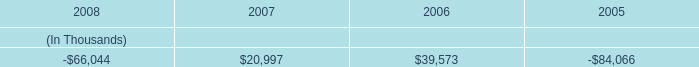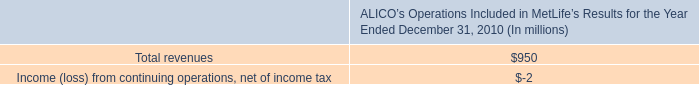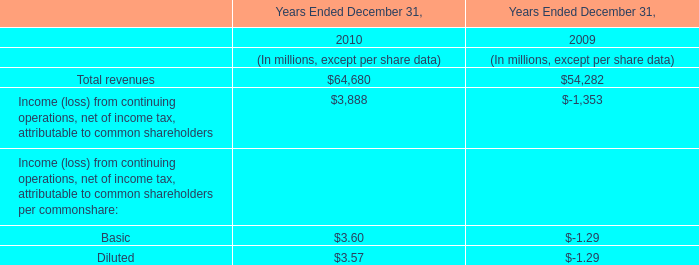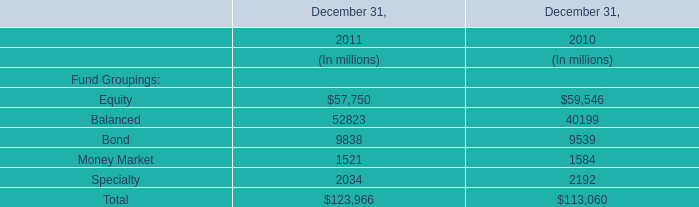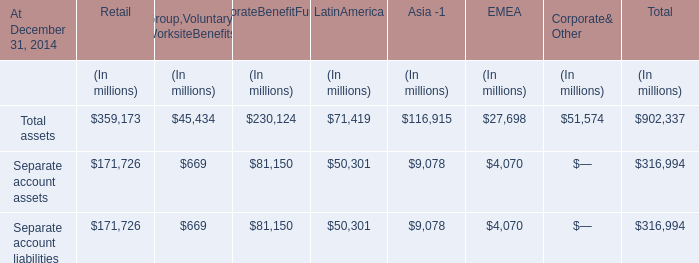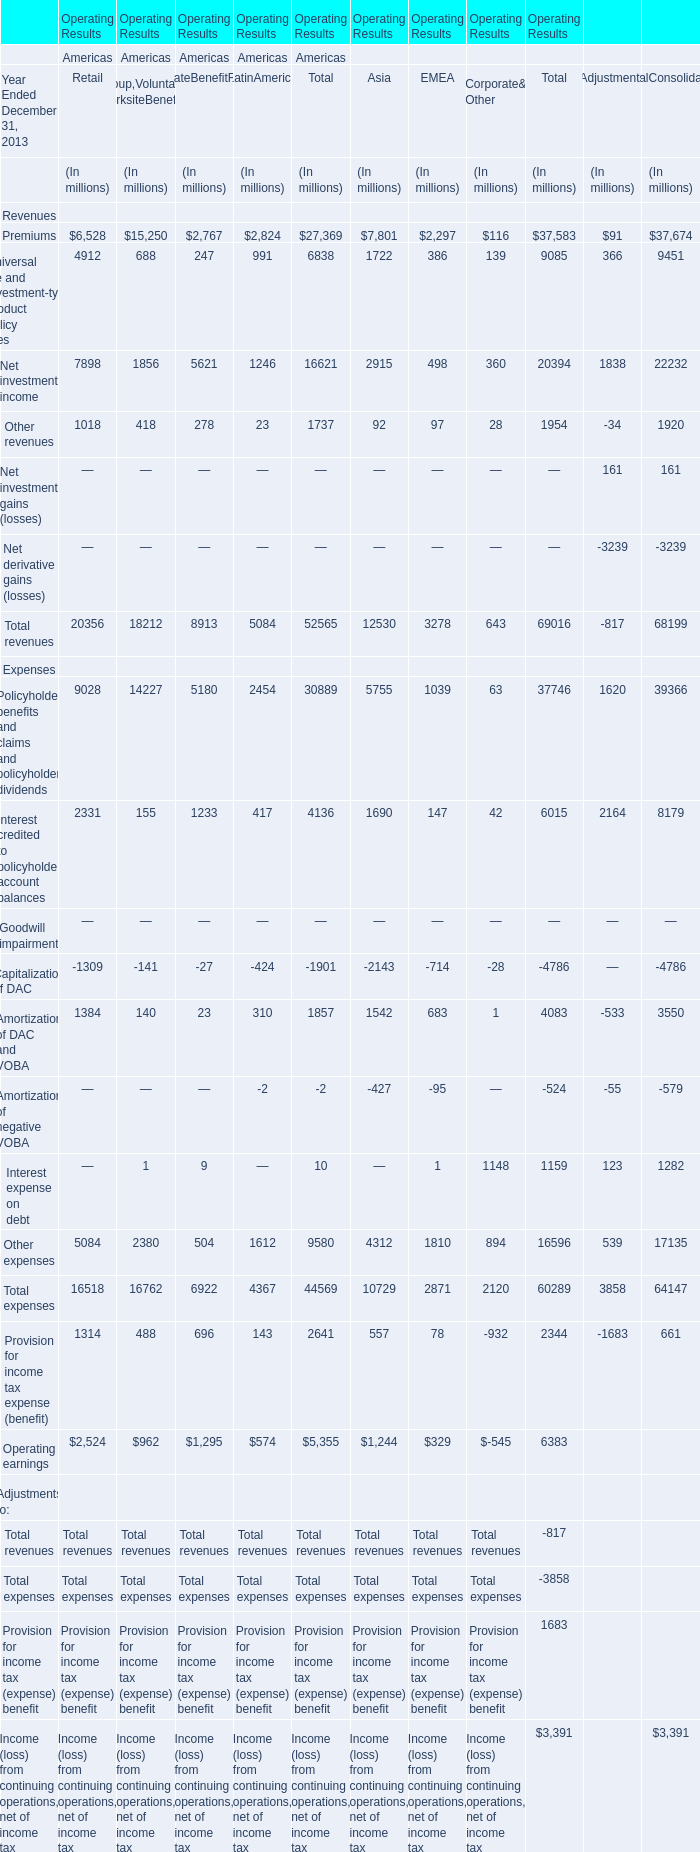Which area's operating results exceeds 1 % of total America's Total Premiums of Revenues in 2013? 
Answer: Asia, EMEA. 